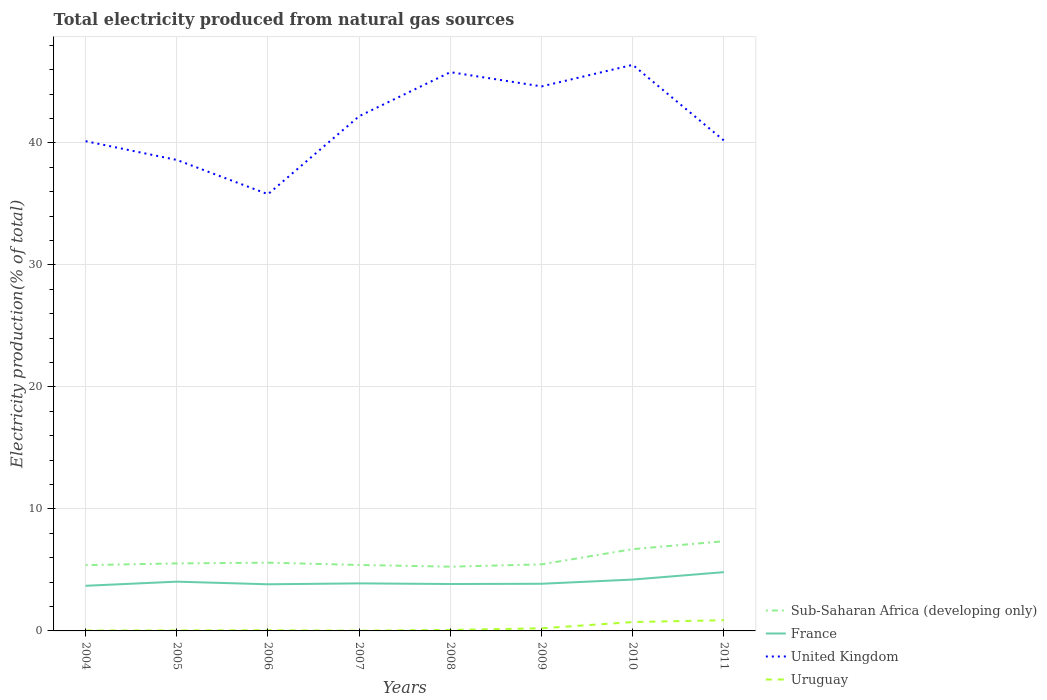How many different coloured lines are there?
Keep it short and to the point. 4. Is the number of lines equal to the number of legend labels?
Your response must be concise. Yes. Across all years, what is the maximum total electricity produced in Uruguay?
Offer a terse response. 0.02. In which year was the total electricity produced in United Kingdom maximum?
Give a very brief answer. 2006. What is the total total electricity produced in Uruguay in the graph?
Your response must be concise. -0.06. What is the difference between the highest and the second highest total electricity produced in France?
Offer a very short reply. 1.12. What is the difference between the highest and the lowest total electricity produced in Uruguay?
Provide a short and direct response. 2. Is the total electricity produced in Sub-Saharan Africa (developing only) strictly greater than the total electricity produced in United Kingdom over the years?
Make the answer very short. Yes. How many lines are there?
Provide a short and direct response. 4. How many years are there in the graph?
Give a very brief answer. 8. Does the graph contain grids?
Your answer should be very brief. Yes. Where does the legend appear in the graph?
Make the answer very short. Bottom right. What is the title of the graph?
Keep it short and to the point. Total electricity produced from natural gas sources. What is the label or title of the X-axis?
Your answer should be compact. Years. What is the Electricity production(% of total) in Sub-Saharan Africa (developing only) in 2004?
Make the answer very short. 5.39. What is the Electricity production(% of total) in France in 2004?
Offer a very short reply. 3.7. What is the Electricity production(% of total) of United Kingdom in 2004?
Offer a very short reply. 40.14. What is the Electricity production(% of total) in Uruguay in 2004?
Offer a very short reply. 0.03. What is the Electricity production(% of total) of Sub-Saharan Africa (developing only) in 2005?
Offer a very short reply. 5.53. What is the Electricity production(% of total) in France in 2005?
Your response must be concise. 4.04. What is the Electricity production(% of total) of United Kingdom in 2005?
Give a very brief answer. 38.6. What is the Electricity production(% of total) in Uruguay in 2005?
Keep it short and to the point. 0.04. What is the Electricity production(% of total) of Sub-Saharan Africa (developing only) in 2006?
Give a very brief answer. 5.59. What is the Electricity production(% of total) in France in 2006?
Offer a terse response. 3.82. What is the Electricity production(% of total) of United Kingdom in 2006?
Ensure brevity in your answer.  35.8. What is the Electricity production(% of total) in Uruguay in 2006?
Your answer should be very brief. 0.05. What is the Electricity production(% of total) in Sub-Saharan Africa (developing only) in 2007?
Offer a terse response. 5.41. What is the Electricity production(% of total) of France in 2007?
Your answer should be compact. 3.9. What is the Electricity production(% of total) in United Kingdom in 2007?
Keep it short and to the point. 42.19. What is the Electricity production(% of total) in Uruguay in 2007?
Offer a terse response. 0.02. What is the Electricity production(% of total) in Sub-Saharan Africa (developing only) in 2008?
Make the answer very short. 5.27. What is the Electricity production(% of total) in France in 2008?
Make the answer very short. 3.84. What is the Electricity production(% of total) in United Kingdom in 2008?
Your answer should be compact. 45.8. What is the Electricity production(% of total) in Uruguay in 2008?
Give a very brief answer. 0.08. What is the Electricity production(% of total) of Sub-Saharan Africa (developing only) in 2009?
Offer a very short reply. 5.46. What is the Electricity production(% of total) of France in 2009?
Provide a succinct answer. 3.86. What is the Electricity production(% of total) of United Kingdom in 2009?
Your response must be concise. 44.63. What is the Electricity production(% of total) in Uruguay in 2009?
Keep it short and to the point. 0.21. What is the Electricity production(% of total) in Sub-Saharan Africa (developing only) in 2010?
Your answer should be very brief. 6.7. What is the Electricity production(% of total) in France in 2010?
Your answer should be very brief. 4.21. What is the Electricity production(% of total) of United Kingdom in 2010?
Give a very brief answer. 46.39. What is the Electricity production(% of total) in Uruguay in 2010?
Give a very brief answer. 0.73. What is the Electricity production(% of total) in Sub-Saharan Africa (developing only) in 2011?
Offer a very short reply. 7.35. What is the Electricity production(% of total) of France in 2011?
Give a very brief answer. 4.82. What is the Electricity production(% of total) in United Kingdom in 2011?
Your response must be concise. 40.19. What is the Electricity production(% of total) in Uruguay in 2011?
Offer a terse response. 0.88. Across all years, what is the maximum Electricity production(% of total) in Sub-Saharan Africa (developing only)?
Keep it short and to the point. 7.35. Across all years, what is the maximum Electricity production(% of total) in France?
Your response must be concise. 4.82. Across all years, what is the maximum Electricity production(% of total) of United Kingdom?
Your answer should be compact. 46.39. Across all years, what is the maximum Electricity production(% of total) of Uruguay?
Your answer should be very brief. 0.88. Across all years, what is the minimum Electricity production(% of total) in Sub-Saharan Africa (developing only)?
Keep it short and to the point. 5.27. Across all years, what is the minimum Electricity production(% of total) in France?
Keep it short and to the point. 3.7. Across all years, what is the minimum Electricity production(% of total) of United Kingdom?
Provide a succinct answer. 35.8. Across all years, what is the minimum Electricity production(% of total) of Uruguay?
Ensure brevity in your answer.  0.02. What is the total Electricity production(% of total) of Sub-Saharan Africa (developing only) in the graph?
Give a very brief answer. 46.7. What is the total Electricity production(% of total) of France in the graph?
Your answer should be compact. 32.2. What is the total Electricity production(% of total) in United Kingdom in the graph?
Make the answer very short. 333.74. What is the total Electricity production(% of total) in Uruguay in the graph?
Give a very brief answer. 2.05. What is the difference between the Electricity production(% of total) of Sub-Saharan Africa (developing only) in 2004 and that in 2005?
Your response must be concise. -0.14. What is the difference between the Electricity production(% of total) of France in 2004 and that in 2005?
Offer a terse response. -0.34. What is the difference between the Electricity production(% of total) of United Kingdom in 2004 and that in 2005?
Your answer should be compact. 1.54. What is the difference between the Electricity production(% of total) in Uruguay in 2004 and that in 2005?
Provide a short and direct response. -0.01. What is the difference between the Electricity production(% of total) in Sub-Saharan Africa (developing only) in 2004 and that in 2006?
Provide a succinct answer. -0.2. What is the difference between the Electricity production(% of total) of France in 2004 and that in 2006?
Keep it short and to the point. -0.12. What is the difference between the Electricity production(% of total) in United Kingdom in 2004 and that in 2006?
Offer a terse response. 4.35. What is the difference between the Electricity production(% of total) in Uruguay in 2004 and that in 2006?
Ensure brevity in your answer.  -0.02. What is the difference between the Electricity production(% of total) in Sub-Saharan Africa (developing only) in 2004 and that in 2007?
Make the answer very short. -0.01. What is the difference between the Electricity production(% of total) in France in 2004 and that in 2007?
Offer a very short reply. -0.2. What is the difference between the Electricity production(% of total) in United Kingdom in 2004 and that in 2007?
Your response must be concise. -2.05. What is the difference between the Electricity production(% of total) of Uruguay in 2004 and that in 2007?
Ensure brevity in your answer.  0.01. What is the difference between the Electricity production(% of total) in Sub-Saharan Africa (developing only) in 2004 and that in 2008?
Your answer should be very brief. 0.13. What is the difference between the Electricity production(% of total) in France in 2004 and that in 2008?
Provide a short and direct response. -0.14. What is the difference between the Electricity production(% of total) of United Kingdom in 2004 and that in 2008?
Ensure brevity in your answer.  -5.66. What is the difference between the Electricity production(% of total) in Uruguay in 2004 and that in 2008?
Your response must be concise. -0.05. What is the difference between the Electricity production(% of total) in Sub-Saharan Africa (developing only) in 2004 and that in 2009?
Keep it short and to the point. -0.06. What is the difference between the Electricity production(% of total) of France in 2004 and that in 2009?
Make the answer very short. -0.17. What is the difference between the Electricity production(% of total) in United Kingdom in 2004 and that in 2009?
Your answer should be very brief. -4.49. What is the difference between the Electricity production(% of total) in Uruguay in 2004 and that in 2009?
Make the answer very short. -0.18. What is the difference between the Electricity production(% of total) in Sub-Saharan Africa (developing only) in 2004 and that in 2010?
Your response must be concise. -1.31. What is the difference between the Electricity production(% of total) of France in 2004 and that in 2010?
Provide a short and direct response. -0.51. What is the difference between the Electricity production(% of total) of United Kingdom in 2004 and that in 2010?
Ensure brevity in your answer.  -6.25. What is the difference between the Electricity production(% of total) of Uruguay in 2004 and that in 2010?
Your answer should be compact. -0.69. What is the difference between the Electricity production(% of total) of Sub-Saharan Africa (developing only) in 2004 and that in 2011?
Offer a terse response. -1.96. What is the difference between the Electricity production(% of total) of France in 2004 and that in 2011?
Keep it short and to the point. -1.12. What is the difference between the Electricity production(% of total) of United Kingdom in 2004 and that in 2011?
Offer a very short reply. -0.05. What is the difference between the Electricity production(% of total) in Uruguay in 2004 and that in 2011?
Offer a terse response. -0.85. What is the difference between the Electricity production(% of total) in Sub-Saharan Africa (developing only) in 2005 and that in 2006?
Give a very brief answer. -0.06. What is the difference between the Electricity production(% of total) in France in 2005 and that in 2006?
Make the answer very short. 0.21. What is the difference between the Electricity production(% of total) in United Kingdom in 2005 and that in 2006?
Provide a short and direct response. 2.81. What is the difference between the Electricity production(% of total) in Uruguay in 2005 and that in 2006?
Make the answer very short. -0.01. What is the difference between the Electricity production(% of total) of Sub-Saharan Africa (developing only) in 2005 and that in 2007?
Your answer should be very brief. 0.13. What is the difference between the Electricity production(% of total) in France in 2005 and that in 2007?
Offer a terse response. 0.14. What is the difference between the Electricity production(% of total) in United Kingdom in 2005 and that in 2007?
Ensure brevity in your answer.  -3.59. What is the difference between the Electricity production(% of total) in Uruguay in 2005 and that in 2007?
Provide a short and direct response. 0.02. What is the difference between the Electricity production(% of total) in Sub-Saharan Africa (developing only) in 2005 and that in 2008?
Offer a terse response. 0.27. What is the difference between the Electricity production(% of total) of France in 2005 and that in 2008?
Offer a very short reply. 0.19. What is the difference between the Electricity production(% of total) of United Kingdom in 2005 and that in 2008?
Your answer should be very brief. -7.2. What is the difference between the Electricity production(% of total) in Uruguay in 2005 and that in 2008?
Offer a very short reply. -0.04. What is the difference between the Electricity production(% of total) of Sub-Saharan Africa (developing only) in 2005 and that in 2009?
Ensure brevity in your answer.  0.08. What is the difference between the Electricity production(% of total) in France in 2005 and that in 2009?
Keep it short and to the point. 0.17. What is the difference between the Electricity production(% of total) of United Kingdom in 2005 and that in 2009?
Give a very brief answer. -6.03. What is the difference between the Electricity production(% of total) in Uruguay in 2005 and that in 2009?
Offer a terse response. -0.18. What is the difference between the Electricity production(% of total) of Sub-Saharan Africa (developing only) in 2005 and that in 2010?
Offer a terse response. -1.17. What is the difference between the Electricity production(% of total) of France in 2005 and that in 2010?
Offer a terse response. -0.17. What is the difference between the Electricity production(% of total) of United Kingdom in 2005 and that in 2010?
Keep it short and to the point. -7.79. What is the difference between the Electricity production(% of total) in Uruguay in 2005 and that in 2010?
Offer a terse response. -0.69. What is the difference between the Electricity production(% of total) in Sub-Saharan Africa (developing only) in 2005 and that in 2011?
Your response must be concise. -1.82. What is the difference between the Electricity production(% of total) in France in 2005 and that in 2011?
Ensure brevity in your answer.  -0.78. What is the difference between the Electricity production(% of total) in United Kingdom in 2005 and that in 2011?
Ensure brevity in your answer.  -1.59. What is the difference between the Electricity production(% of total) in Uruguay in 2005 and that in 2011?
Keep it short and to the point. -0.84. What is the difference between the Electricity production(% of total) in Sub-Saharan Africa (developing only) in 2006 and that in 2007?
Make the answer very short. 0.19. What is the difference between the Electricity production(% of total) of France in 2006 and that in 2007?
Keep it short and to the point. -0.07. What is the difference between the Electricity production(% of total) of United Kingdom in 2006 and that in 2007?
Offer a terse response. -6.39. What is the difference between the Electricity production(% of total) in Uruguay in 2006 and that in 2007?
Your answer should be compact. 0.03. What is the difference between the Electricity production(% of total) in Sub-Saharan Africa (developing only) in 2006 and that in 2008?
Offer a very short reply. 0.33. What is the difference between the Electricity production(% of total) of France in 2006 and that in 2008?
Provide a short and direct response. -0.02. What is the difference between the Electricity production(% of total) in United Kingdom in 2006 and that in 2008?
Your answer should be compact. -10. What is the difference between the Electricity production(% of total) of Uruguay in 2006 and that in 2008?
Provide a succinct answer. -0.03. What is the difference between the Electricity production(% of total) of Sub-Saharan Africa (developing only) in 2006 and that in 2009?
Your response must be concise. 0.14. What is the difference between the Electricity production(% of total) in France in 2006 and that in 2009?
Ensure brevity in your answer.  -0.04. What is the difference between the Electricity production(% of total) in United Kingdom in 2006 and that in 2009?
Keep it short and to the point. -8.83. What is the difference between the Electricity production(% of total) in Uruguay in 2006 and that in 2009?
Give a very brief answer. -0.16. What is the difference between the Electricity production(% of total) in Sub-Saharan Africa (developing only) in 2006 and that in 2010?
Ensure brevity in your answer.  -1.11. What is the difference between the Electricity production(% of total) of France in 2006 and that in 2010?
Keep it short and to the point. -0.39. What is the difference between the Electricity production(% of total) in United Kingdom in 2006 and that in 2010?
Offer a very short reply. -10.6. What is the difference between the Electricity production(% of total) in Uruguay in 2006 and that in 2010?
Provide a succinct answer. -0.67. What is the difference between the Electricity production(% of total) in Sub-Saharan Africa (developing only) in 2006 and that in 2011?
Make the answer very short. -1.76. What is the difference between the Electricity production(% of total) in France in 2006 and that in 2011?
Offer a very short reply. -1. What is the difference between the Electricity production(% of total) in United Kingdom in 2006 and that in 2011?
Your response must be concise. -4.4. What is the difference between the Electricity production(% of total) in Uruguay in 2006 and that in 2011?
Offer a terse response. -0.83. What is the difference between the Electricity production(% of total) in Sub-Saharan Africa (developing only) in 2007 and that in 2008?
Keep it short and to the point. 0.14. What is the difference between the Electricity production(% of total) in France in 2007 and that in 2008?
Your answer should be very brief. 0.05. What is the difference between the Electricity production(% of total) in United Kingdom in 2007 and that in 2008?
Ensure brevity in your answer.  -3.61. What is the difference between the Electricity production(% of total) of Uruguay in 2007 and that in 2008?
Keep it short and to the point. -0.06. What is the difference between the Electricity production(% of total) in Sub-Saharan Africa (developing only) in 2007 and that in 2009?
Provide a succinct answer. -0.05. What is the difference between the Electricity production(% of total) of France in 2007 and that in 2009?
Provide a succinct answer. 0.03. What is the difference between the Electricity production(% of total) of United Kingdom in 2007 and that in 2009?
Ensure brevity in your answer.  -2.44. What is the difference between the Electricity production(% of total) in Uruguay in 2007 and that in 2009?
Your answer should be very brief. -0.19. What is the difference between the Electricity production(% of total) of Sub-Saharan Africa (developing only) in 2007 and that in 2010?
Give a very brief answer. -1.3. What is the difference between the Electricity production(% of total) of France in 2007 and that in 2010?
Give a very brief answer. -0.31. What is the difference between the Electricity production(% of total) in United Kingdom in 2007 and that in 2010?
Offer a very short reply. -4.21. What is the difference between the Electricity production(% of total) of Uruguay in 2007 and that in 2010?
Make the answer very short. -0.71. What is the difference between the Electricity production(% of total) of Sub-Saharan Africa (developing only) in 2007 and that in 2011?
Offer a very short reply. -1.94. What is the difference between the Electricity production(% of total) of France in 2007 and that in 2011?
Offer a terse response. -0.92. What is the difference between the Electricity production(% of total) of United Kingdom in 2007 and that in 2011?
Provide a succinct answer. 2. What is the difference between the Electricity production(% of total) in Uruguay in 2007 and that in 2011?
Provide a succinct answer. -0.86. What is the difference between the Electricity production(% of total) in Sub-Saharan Africa (developing only) in 2008 and that in 2009?
Provide a short and direct response. -0.19. What is the difference between the Electricity production(% of total) in France in 2008 and that in 2009?
Offer a very short reply. -0.02. What is the difference between the Electricity production(% of total) in United Kingdom in 2008 and that in 2009?
Ensure brevity in your answer.  1.17. What is the difference between the Electricity production(% of total) of Uruguay in 2008 and that in 2009?
Make the answer very short. -0.13. What is the difference between the Electricity production(% of total) in Sub-Saharan Africa (developing only) in 2008 and that in 2010?
Offer a very short reply. -1.44. What is the difference between the Electricity production(% of total) of France in 2008 and that in 2010?
Ensure brevity in your answer.  -0.36. What is the difference between the Electricity production(% of total) in United Kingdom in 2008 and that in 2010?
Keep it short and to the point. -0.6. What is the difference between the Electricity production(% of total) of Uruguay in 2008 and that in 2010?
Give a very brief answer. -0.65. What is the difference between the Electricity production(% of total) of Sub-Saharan Africa (developing only) in 2008 and that in 2011?
Your response must be concise. -2.08. What is the difference between the Electricity production(% of total) in France in 2008 and that in 2011?
Keep it short and to the point. -0.97. What is the difference between the Electricity production(% of total) in United Kingdom in 2008 and that in 2011?
Give a very brief answer. 5.6. What is the difference between the Electricity production(% of total) of Uruguay in 2008 and that in 2011?
Give a very brief answer. -0.8. What is the difference between the Electricity production(% of total) in Sub-Saharan Africa (developing only) in 2009 and that in 2010?
Provide a short and direct response. -1.25. What is the difference between the Electricity production(% of total) of France in 2009 and that in 2010?
Your answer should be compact. -0.34. What is the difference between the Electricity production(% of total) in United Kingdom in 2009 and that in 2010?
Make the answer very short. -1.77. What is the difference between the Electricity production(% of total) of Uruguay in 2009 and that in 2010?
Offer a terse response. -0.51. What is the difference between the Electricity production(% of total) of Sub-Saharan Africa (developing only) in 2009 and that in 2011?
Make the answer very short. -1.9. What is the difference between the Electricity production(% of total) of France in 2009 and that in 2011?
Ensure brevity in your answer.  -0.95. What is the difference between the Electricity production(% of total) of United Kingdom in 2009 and that in 2011?
Make the answer very short. 4.44. What is the difference between the Electricity production(% of total) in Uruguay in 2009 and that in 2011?
Give a very brief answer. -0.67. What is the difference between the Electricity production(% of total) of Sub-Saharan Africa (developing only) in 2010 and that in 2011?
Keep it short and to the point. -0.65. What is the difference between the Electricity production(% of total) in France in 2010 and that in 2011?
Make the answer very short. -0.61. What is the difference between the Electricity production(% of total) in United Kingdom in 2010 and that in 2011?
Make the answer very short. 6.2. What is the difference between the Electricity production(% of total) of Uruguay in 2010 and that in 2011?
Give a very brief answer. -0.15. What is the difference between the Electricity production(% of total) of Sub-Saharan Africa (developing only) in 2004 and the Electricity production(% of total) of France in 2005?
Provide a succinct answer. 1.36. What is the difference between the Electricity production(% of total) in Sub-Saharan Africa (developing only) in 2004 and the Electricity production(% of total) in United Kingdom in 2005?
Your answer should be compact. -33.21. What is the difference between the Electricity production(% of total) in Sub-Saharan Africa (developing only) in 2004 and the Electricity production(% of total) in Uruguay in 2005?
Provide a short and direct response. 5.36. What is the difference between the Electricity production(% of total) of France in 2004 and the Electricity production(% of total) of United Kingdom in 2005?
Offer a very short reply. -34.9. What is the difference between the Electricity production(% of total) in France in 2004 and the Electricity production(% of total) in Uruguay in 2005?
Provide a short and direct response. 3.66. What is the difference between the Electricity production(% of total) in United Kingdom in 2004 and the Electricity production(% of total) in Uruguay in 2005?
Provide a short and direct response. 40.1. What is the difference between the Electricity production(% of total) of Sub-Saharan Africa (developing only) in 2004 and the Electricity production(% of total) of France in 2006?
Your response must be concise. 1.57. What is the difference between the Electricity production(% of total) of Sub-Saharan Africa (developing only) in 2004 and the Electricity production(% of total) of United Kingdom in 2006?
Give a very brief answer. -30.4. What is the difference between the Electricity production(% of total) of Sub-Saharan Africa (developing only) in 2004 and the Electricity production(% of total) of Uruguay in 2006?
Make the answer very short. 5.34. What is the difference between the Electricity production(% of total) of France in 2004 and the Electricity production(% of total) of United Kingdom in 2006?
Provide a succinct answer. -32.1. What is the difference between the Electricity production(% of total) of France in 2004 and the Electricity production(% of total) of Uruguay in 2006?
Keep it short and to the point. 3.65. What is the difference between the Electricity production(% of total) in United Kingdom in 2004 and the Electricity production(% of total) in Uruguay in 2006?
Your response must be concise. 40.09. What is the difference between the Electricity production(% of total) in Sub-Saharan Africa (developing only) in 2004 and the Electricity production(% of total) in France in 2007?
Make the answer very short. 1.5. What is the difference between the Electricity production(% of total) of Sub-Saharan Africa (developing only) in 2004 and the Electricity production(% of total) of United Kingdom in 2007?
Give a very brief answer. -36.8. What is the difference between the Electricity production(% of total) in Sub-Saharan Africa (developing only) in 2004 and the Electricity production(% of total) in Uruguay in 2007?
Offer a terse response. 5.37. What is the difference between the Electricity production(% of total) in France in 2004 and the Electricity production(% of total) in United Kingdom in 2007?
Give a very brief answer. -38.49. What is the difference between the Electricity production(% of total) of France in 2004 and the Electricity production(% of total) of Uruguay in 2007?
Provide a succinct answer. 3.68. What is the difference between the Electricity production(% of total) of United Kingdom in 2004 and the Electricity production(% of total) of Uruguay in 2007?
Make the answer very short. 40.12. What is the difference between the Electricity production(% of total) in Sub-Saharan Africa (developing only) in 2004 and the Electricity production(% of total) in France in 2008?
Make the answer very short. 1.55. What is the difference between the Electricity production(% of total) of Sub-Saharan Africa (developing only) in 2004 and the Electricity production(% of total) of United Kingdom in 2008?
Ensure brevity in your answer.  -40.4. What is the difference between the Electricity production(% of total) of Sub-Saharan Africa (developing only) in 2004 and the Electricity production(% of total) of Uruguay in 2008?
Your answer should be very brief. 5.31. What is the difference between the Electricity production(% of total) in France in 2004 and the Electricity production(% of total) in United Kingdom in 2008?
Keep it short and to the point. -42.1. What is the difference between the Electricity production(% of total) of France in 2004 and the Electricity production(% of total) of Uruguay in 2008?
Give a very brief answer. 3.62. What is the difference between the Electricity production(% of total) in United Kingdom in 2004 and the Electricity production(% of total) in Uruguay in 2008?
Your answer should be compact. 40.06. What is the difference between the Electricity production(% of total) in Sub-Saharan Africa (developing only) in 2004 and the Electricity production(% of total) in France in 2009?
Provide a succinct answer. 1.53. What is the difference between the Electricity production(% of total) in Sub-Saharan Africa (developing only) in 2004 and the Electricity production(% of total) in United Kingdom in 2009?
Your response must be concise. -39.24. What is the difference between the Electricity production(% of total) of Sub-Saharan Africa (developing only) in 2004 and the Electricity production(% of total) of Uruguay in 2009?
Provide a succinct answer. 5.18. What is the difference between the Electricity production(% of total) in France in 2004 and the Electricity production(% of total) in United Kingdom in 2009?
Make the answer very short. -40.93. What is the difference between the Electricity production(% of total) of France in 2004 and the Electricity production(% of total) of Uruguay in 2009?
Provide a succinct answer. 3.49. What is the difference between the Electricity production(% of total) of United Kingdom in 2004 and the Electricity production(% of total) of Uruguay in 2009?
Keep it short and to the point. 39.93. What is the difference between the Electricity production(% of total) of Sub-Saharan Africa (developing only) in 2004 and the Electricity production(% of total) of France in 2010?
Your answer should be compact. 1.18. What is the difference between the Electricity production(% of total) of Sub-Saharan Africa (developing only) in 2004 and the Electricity production(% of total) of United Kingdom in 2010?
Give a very brief answer. -41. What is the difference between the Electricity production(% of total) in Sub-Saharan Africa (developing only) in 2004 and the Electricity production(% of total) in Uruguay in 2010?
Your answer should be compact. 4.67. What is the difference between the Electricity production(% of total) of France in 2004 and the Electricity production(% of total) of United Kingdom in 2010?
Offer a terse response. -42.7. What is the difference between the Electricity production(% of total) of France in 2004 and the Electricity production(% of total) of Uruguay in 2010?
Keep it short and to the point. 2.97. What is the difference between the Electricity production(% of total) in United Kingdom in 2004 and the Electricity production(% of total) in Uruguay in 2010?
Offer a terse response. 39.41. What is the difference between the Electricity production(% of total) in Sub-Saharan Africa (developing only) in 2004 and the Electricity production(% of total) in France in 2011?
Your answer should be compact. 0.58. What is the difference between the Electricity production(% of total) in Sub-Saharan Africa (developing only) in 2004 and the Electricity production(% of total) in United Kingdom in 2011?
Your response must be concise. -34.8. What is the difference between the Electricity production(% of total) of Sub-Saharan Africa (developing only) in 2004 and the Electricity production(% of total) of Uruguay in 2011?
Provide a short and direct response. 4.51. What is the difference between the Electricity production(% of total) in France in 2004 and the Electricity production(% of total) in United Kingdom in 2011?
Provide a succinct answer. -36.49. What is the difference between the Electricity production(% of total) of France in 2004 and the Electricity production(% of total) of Uruguay in 2011?
Your answer should be compact. 2.82. What is the difference between the Electricity production(% of total) in United Kingdom in 2004 and the Electricity production(% of total) in Uruguay in 2011?
Offer a very short reply. 39.26. What is the difference between the Electricity production(% of total) of Sub-Saharan Africa (developing only) in 2005 and the Electricity production(% of total) of France in 2006?
Your answer should be compact. 1.71. What is the difference between the Electricity production(% of total) in Sub-Saharan Africa (developing only) in 2005 and the Electricity production(% of total) in United Kingdom in 2006?
Your response must be concise. -30.26. What is the difference between the Electricity production(% of total) of Sub-Saharan Africa (developing only) in 2005 and the Electricity production(% of total) of Uruguay in 2006?
Provide a succinct answer. 5.48. What is the difference between the Electricity production(% of total) in France in 2005 and the Electricity production(% of total) in United Kingdom in 2006?
Your answer should be compact. -31.76. What is the difference between the Electricity production(% of total) of France in 2005 and the Electricity production(% of total) of Uruguay in 2006?
Offer a very short reply. 3.98. What is the difference between the Electricity production(% of total) of United Kingdom in 2005 and the Electricity production(% of total) of Uruguay in 2006?
Make the answer very short. 38.55. What is the difference between the Electricity production(% of total) of Sub-Saharan Africa (developing only) in 2005 and the Electricity production(% of total) of France in 2007?
Offer a terse response. 1.64. What is the difference between the Electricity production(% of total) of Sub-Saharan Africa (developing only) in 2005 and the Electricity production(% of total) of United Kingdom in 2007?
Offer a terse response. -36.66. What is the difference between the Electricity production(% of total) of Sub-Saharan Africa (developing only) in 2005 and the Electricity production(% of total) of Uruguay in 2007?
Offer a terse response. 5.51. What is the difference between the Electricity production(% of total) of France in 2005 and the Electricity production(% of total) of United Kingdom in 2007?
Your response must be concise. -38.15. What is the difference between the Electricity production(% of total) in France in 2005 and the Electricity production(% of total) in Uruguay in 2007?
Give a very brief answer. 4.02. What is the difference between the Electricity production(% of total) of United Kingdom in 2005 and the Electricity production(% of total) of Uruguay in 2007?
Your answer should be compact. 38.58. What is the difference between the Electricity production(% of total) of Sub-Saharan Africa (developing only) in 2005 and the Electricity production(% of total) of France in 2008?
Offer a very short reply. 1.69. What is the difference between the Electricity production(% of total) in Sub-Saharan Africa (developing only) in 2005 and the Electricity production(% of total) in United Kingdom in 2008?
Keep it short and to the point. -40.26. What is the difference between the Electricity production(% of total) in Sub-Saharan Africa (developing only) in 2005 and the Electricity production(% of total) in Uruguay in 2008?
Offer a very short reply. 5.45. What is the difference between the Electricity production(% of total) of France in 2005 and the Electricity production(% of total) of United Kingdom in 2008?
Give a very brief answer. -41.76. What is the difference between the Electricity production(% of total) in France in 2005 and the Electricity production(% of total) in Uruguay in 2008?
Provide a succinct answer. 3.96. What is the difference between the Electricity production(% of total) in United Kingdom in 2005 and the Electricity production(% of total) in Uruguay in 2008?
Your answer should be compact. 38.52. What is the difference between the Electricity production(% of total) of Sub-Saharan Africa (developing only) in 2005 and the Electricity production(% of total) of France in 2009?
Your answer should be very brief. 1.67. What is the difference between the Electricity production(% of total) of Sub-Saharan Africa (developing only) in 2005 and the Electricity production(% of total) of United Kingdom in 2009?
Give a very brief answer. -39.1. What is the difference between the Electricity production(% of total) in Sub-Saharan Africa (developing only) in 2005 and the Electricity production(% of total) in Uruguay in 2009?
Your answer should be compact. 5.32. What is the difference between the Electricity production(% of total) in France in 2005 and the Electricity production(% of total) in United Kingdom in 2009?
Provide a succinct answer. -40.59. What is the difference between the Electricity production(% of total) in France in 2005 and the Electricity production(% of total) in Uruguay in 2009?
Make the answer very short. 3.82. What is the difference between the Electricity production(% of total) of United Kingdom in 2005 and the Electricity production(% of total) of Uruguay in 2009?
Your answer should be compact. 38.39. What is the difference between the Electricity production(% of total) of Sub-Saharan Africa (developing only) in 2005 and the Electricity production(% of total) of France in 2010?
Ensure brevity in your answer.  1.32. What is the difference between the Electricity production(% of total) of Sub-Saharan Africa (developing only) in 2005 and the Electricity production(% of total) of United Kingdom in 2010?
Provide a short and direct response. -40.86. What is the difference between the Electricity production(% of total) of Sub-Saharan Africa (developing only) in 2005 and the Electricity production(% of total) of Uruguay in 2010?
Your answer should be compact. 4.8. What is the difference between the Electricity production(% of total) of France in 2005 and the Electricity production(% of total) of United Kingdom in 2010?
Ensure brevity in your answer.  -42.36. What is the difference between the Electricity production(% of total) of France in 2005 and the Electricity production(% of total) of Uruguay in 2010?
Give a very brief answer. 3.31. What is the difference between the Electricity production(% of total) in United Kingdom in 2005 and the Electricity production(% of total) in Uruguay in 2010?
Your answer should be compact. 37.87. What is the difference between the Electricity production(% of total) in Sub-Saharan Africa (developing only) in 2005 and the Electricity production(% of total) in France in 2011?
Your answer should be very brief. 0.71. What is the difference between the Electricity production(% of total) of Sub-Saharan Africa (developing only) in 2005 and the Electricity production(% of total) of United Kingdom in 2011?
Make the answer very short. -34.66. What is the difference between the Electricity production(% of total) in Sub-Saharan Africa (developing only) in 2005 and the Electricity production(% of total) in Uruguay in 2011?
Your response must be concise. 4.65. What is the difference between the Electricity production(% of total) in France in 2005 and the Electricity production(% of total) in United Kingdom in 2011?
Your answer should be compact. -36.15. What is the difference between the Electricity production(% of total) of France in 2005 and the Electricity production(% of total) of Uruguay in 2011?
Your answer should be very brief. 3.16. What is the difference between the Electricity production(% of total) in United Kingdom in 2005 and the Electricity production(% of total) in Uruguay in 2011?
Your answer should be compact. 37.72. What is the difference between the Electricity production(% of total) of Sub-Saharan Africa (developing only) in 2006 and the Electricity production(% of total) of France in 2007?
Your answer should be compact. 1.7. What is the difference between the Electricity production(% of total) in Sub-Saharan Africa (developing only) in 2006 and the Electricity production(% of total) in United Kingdom in 2007?
Make the answer very short. -36.6. What is the difference between the Electricity production(% of total) of Sub-Saharan Africa (developing only) in 2006 and the Electricity production(% of total) of Uruguay in 2007?
Keep it short and to the point. 5.57. What is the difference between the Electricity production(% of total) of France in 2006 and the Electricity production(% of total) of United Kingdom in 2007?
Provide a succinct answer. -38.37. What is the difference between the Electricity production(% of total) in France in 2006 and the Electricity production(% of total) in Uruguay in 2007?
Offer a very short reply. 3.8. What is the difference between the Electricity production(% of total) of United Kingdom in 2006 and the Electricity production(% of total) of Uruguay in 2007?
Provide a short and direct response. 35.77. What is the difference between the Electricity production(% of total) of Sub-Saharan Africa (developing only) in 2006 and the Electricity production(% of total) of France in 2008?
Your answer should be very brief. 1.75. What is the difference between the Electricity production(% of total) of Sub-Saharan Africa (developing only) in 2006 and the Electricity production(% of total) of United Kingdom in 2008?
Ensure brevity in your answer.  -40.2. What is the difference between the Electricity production(% of total) of Sub-Saharan Africa (developing only) in 2006 and the Electricity production(% of total) of Uruguay in 2008?
Keep it short and to the point. 5.51. What is the difference between the Electricity production(% of total) in France in 2006 and the Electricity production(% of total) in United Kingdom in 2008?
Offer a very short reply. -41.97. What is the difference between the Electricity production(% of total) of France in 2006 and the Electricity production(% of total) of Uruguay in 2008?
Ensure brevity in your answer.  3.74. What is the difference between the Electricity production(% of total) of United Kingdom in 2006 and the Electricity production(% of total) of Uruguay in 2008?
Your response must be concise. 35.72. What is the difference between the Electricity production(% of total) of Sub-Saharan Africa (developing only) in 2006 and the Electricity production(% of total) of France in 2009?
Offer a very short reply. 1.73. What is the difference between the Electricity production(% of total) of Sub-Saharan Africa (developing only) in 2006 and the Electricity production(% of total) of United Kingdom in 2009?
Offer a very short reply. -39.04. What is the difference between the Electricity production(% of total) in Sub-Saharan Africa (developing only) in 2006 and the Electricity production(% of total) in Uruguay in 2009?
Your answer should be very brief. 5.38. What is the difference between the Electricity production(% of total) in France in 2006 and the Electricity production(% of total) in United Kingdom in 2009?
Keep it short and to the point. -40.81. What is the difference between the Electricity production(% of total) in France in 2006 and the Electricity production(% of total) in Uruguay in 2009?
Give a very brief answer. 3.61. What is the difference between the Electricity production(% of total) in United Kingdom in 2006 and the Electricity production(% of total) in Uruguay in 2009?
Your response must be concise. 35.58. What is the difference between the Electricity production(% of total) of Sub-Saharan Africa (developing only) in 2006 and the Electricity production(% of total) of France in 2010?
Your response must be concise. 1.38. What is the difference between the Electricity production(% of total) in Sub-Saharan Africa (developing only) in 2006 and the Electricity production(% of total) in United Kingdom in 2010?
Your answer should be compact. -40.8. What is the difference between the Electricity production(% of total) in Sub-Saharan Africa (developing only) in 2006 and the Electricity production(% of total) in Uruguay in 2010?
Your answer should be compact. 4.87. What is the difference between the Electricity production(% of total) of France in 2006 and the Electricity production(% of total) of United Kingdom in 2010?
Offer a terse response. -42.57. What is the difference between the Electricity production(% of total) in France in 2006 and the Electricity production(% of total) in Uruguay in 2010?
Give a very brief answer. 3.1. What is the difference between the Electricity production(% of total) in United Kingdom in 2006 and the Electricity production(% of total) in Uruguay in 2010?
Keep it short and to the point. 35.07. What is the difference between the Electricity production(% of total) in Sub-Saharan Africa (developing only) in 2006 and the Electricity production(% of total) in France in 2011?
Make the answer very short. 0.77. What is the difference between the Electricity production(% of total) of Sub-Saharan Africa (developing only) in 2006 and the Electricity production(% of total) of United Kingdom in 2011?
Your answer should be very brief. -34.6. What is the difference between the Electricity production(% of total) in Sub-Saharan Africa (developing only) in 2006 and the Electricity production(% of total) in Uruguay in 2011?
Your response must be concise. 4.71. What is the difference between the Electricity production(% of total) of France in 2006 and the Electricity production(% of total) of United Kingdom in 2011?
Give a very brief answer. -36.37. What is the difference between the Electricity production(% of total) in France in 2006 and the Electricity production(% of total) in Uruguay in 2011?
Ensure brevity in your answer.  2.94. What is the difference between the Electricity production(% of total) of United Kingdom in 2006 and the Electricity production(% of total) of Uruguay in 2011?
Your answer should be compact. 34.92. What is the difference between the Electricity production(% of total) of Sub-Saharan Africa (developing only) in 2007 and the Electricity production(% of total) of France in 2008?
Your response must be concise. 1.56. What is the difference between the Electricity production(% of total) in Sub-Saharan Africa (developing only) in 2007 and the Electricity production(% of total) in United Kingdom in 2008?
Offer a terse response. -40.39. What is the difference between the Electricity production(% of total) of Sub-Saharan Africa (developing only) in 2007 and the Electricity production(% of total) of Uruguay in 2008?
Provide a succinct answer. 5.33. What is the difference between the Electricity production(% of total) in France in 2007 and the Electricity production(% of total) in United Kingdom in 2008?
Your answer should be compact. -41.9. What is the difference between the Electricity production(% of total) of France in 2007 and the Electricity production(% of total) of Uruguay in 2008?
Make the answer very short. 3.82. What is the difference between the Electricity production(% of total) of United Kingdom in 2007 and the Electricity production(% of total) of Uruguay in 2008?
Give a very brief answer. 42.11. What is the difference between the Electricity production(% of total) of Sub-Saharan Africa (developing only) in 2007 and the Electricity production(% of total) of France in 2009?
Your response must be concise. 1.54. What is the difference between the Electricity production(% of total) of Sub-Saharan Africa (developing only) in 2007 and the Electricity production(% of total) of United Kingdom in 2009?
Offer a very short reply. -39.22. What is the difference between the Electricity production(% of total) of Sub-Saharan Africa (developing only) in 2007 and the Electricity production(% of total) of Uruguay in 2009?
Provide a succinct answer. 5.19. What is the difference between the Electricity production(% of total) of France in 2007 and the Electricity production(% of total) of United Kingdom in 2009?
Offer a terse response. -40.73. What is the difference between the Electricity production(% of total) in France in 2007 and the Electricity production(% of total) in Uruguay in 2009?
Ensure brevity in your answer.  3.68. What is the difference between the Electricity production(% of total) in United Kingdom in 2007 and the Electricity production(% of total) in Uruguay in 2009?
Offer a terse response. 41.98. What is the difference between the Electricity production(% of total) of Sub-Saharan Africa (developing only) in 2007 and the Electricity production(% of total) of France in 2010?
Offer a terse response. 1.2. What is the difference between the Electricity production(% of total) in Sub-Saharan Africa (developing only) in 2007 and the Electricity production(% of total) in United Kingdom in 2010?
Make the answer very short. -40.99. What is the difference between the Electricity production(% of total) in Sub-Saharan Africa (developing only) in 2007 and the Electricity production(% of total) in Uruguay in 2010?
Your answer should be compact. 4.68. What is the difference between the Electricity production(% of total) in France in 2007 and the Electricity production(% of total) in United Kingdom in 2010?
Your answer should be very brief. -42.5. What is the difference between the Electricity production(% of total) in France in 2007 and the Electricity production(% of total) in Uruguay in 2010?
Ensure brevity in your answer.  3.17. What is the difference between the Electricity production(% of total) of United Kingdom in 2007 and the Electricity production(% of total) of Uruguay in 2010?
Your answer should be very brief. 41.46. What is the difference between the Electricity production(% of total) of Sub-Saharan Africa (developing only) in 2007 and the Electricity production(% of total) of France in 2011?
Your response must be concise. 0.59. What is the difference between the Electricity production(% of total) of Sub-Saharan Africa (developing only) in 2007 and the Electricity production(% of total) of United Kingdom in 2011?
Keep it short and to the point. -34.79. What is the difference between the Electricity production(% of total) in Sub-Saharan Africa (developing only) in 2007 and the Electricity production(% of total) in Uruguay in 2011?
Keep it short and to the point. 4.53. What is the difference between the Electricity production(% of total) in France in 2007 and the Electricity production(% of total) in United Kingdom in 2011?
Provide a succinct answer. -36.29. What is the difference between the Electricity production(% of total) of France in 2007 and the Electricity production(% of total) of Uruguay in 2011?
Ensure brevity in your answer.  3.02. What is the difference between the Electricity production(% of total) in United Kingdom in 2007 and the Electricity production(% of total) in Uruguay in 2011?
Provide a succinct answer. 41.31. What is the difference between the Electricity production(% of total) of Sub-Saharan Africa (developing only) in 2008 and the Electricity production(% of total) of France in 2009?
Offer a very short reply. 1.4. What is the difference between the Electricity production(% of total) of Sub-Saharan Africa (developing only) in 2008 and the Electricity production(% of total) of United Kingdom in 2009?
Your response must be concise. -39.36. What is the difference between the Electricity production(% of total) of Sub-Saharan Africa (developing only) in 2008 and the Electricity production(% of total) of Uruguay in 2009?
Provide a succinct answer. 5.05. What is the difference between the Electricity production(% of total) in France in 2008 and the Electricity production(% of total) in United Kingdom in 2009?
Provide a short and direct response. -40.78. What is the difference between the Electricity production(% of total) in France in 2008 and the Electricity production(% of total) in Uruguay in 2009?
Provide a succinct answer. 3.63. What is the difference between the Electricity production(% of total) of United Kingdom in 2008 and the Electricity production(% of total) of Uruguay in 2009?
Your answer should be very brief. 45.58. What is the difference between the Electricity production(% of total) of Sub-Saharan Africa (developing only) in 2008 and the Electricity production(% of total) of France in 2010?
Offer a terse response. 1.06. What is the difference between the Electricity production(% of total) of Sub-Saharan Africa (developing only) in 2008 and the Electricity production(% of total) of United Kingdom in 2010?
Provide a succinct answer. -41.13. What is the difference between the Electricity production(% of total) in Sub-Saharan Africa (developing only) in 2008 and the Electricity production(% of total) in Uruguay in 2010?
Ensure brevity in your answer.  4.54. What is the difference between the Electricity production(% of total) in France in 2008 and the Electricity production(% of total) in United Kingdom in 2010?
Provide a succinct answer. -42.55. What is the difference between the Electricity production(% of total) in France in 2008 and the Electricity production(% of total) in Uruguay in 2010?
Make the answer very short. 3.12. What is the difference between the Electricity production(% of total) in United Kingdom in 2008 and the Electricity production(% of total) in Uruguay in 2010?
Keep it short and to the point. 45.07. What is the difference between the Electricity production(% of total) in Sub-Saharan Africa (developing only) in 2008 and the Electricity production(% of total) in France in 2011?
Ensure brevity in your answer.  0.45. What is the difference between the Electricity production(% of total) in Sub-Saharan Africa (developing only) in 2008 and the Electricity production(% of total) in United Kingdom in 2011?
Your response must be concise. -34.93. What is the difference between the Electricity production(% of total) of Sub-Saharan Africa (developing only) in 2008 and the Electricity production(% of total) of Uruguay in 2011?
Your response must be concise. 4.39. What is the difference between the Electricity production(% of total) of France in 2008 and the Electricity production(% of total) of United Kingdom in 2011?
Your answer should be compact. -36.35. What is the difference between the Electricity production(% of total) of France in 2008 and the Electricity production(% of total) of Uruguay in 2011?
Give a very brief answer. 2.96. What is the difference between the Electricity production(% of total) of United Kingdom in 2008 and the Electricity production(% of total) of Uruguay in 2011?
Offer a terse response. 44.92. What is the difference between the Electricity production(% of total) in Sub-Saharan Africa (developing only) in 2009 and the Electricity production(% of total) in France in 2010?
Offer a terse response. 1.25. What is the difference between the Electricity production(% of total) in Sub-Saharan Africa (developing only) in 2009 and the Electricity production(% of total) in United Kingdom in 2010?
Provide a short and direct response. -40.94. What is the difference between the Electricity production(% of total) in Sub-Saharan Africa (developing only) in 2009 and the Electricity production(% of total) in Uruguay in 2010?
Make the answer very short. 4.73. What is the difference between the Electricity production(% of total) in France in 2009 and the Electricity production(% of total) in United Kingdom in 2010?
Offer a very short reply. -42.53. What is the difference between the Electricity production(% of total) in France in 2009 and the Electricity production(% of total) in Uruguay in 2010?
Your answer should be very brief. 3.14. What is the difference between the Electricity production(% of total) of United Kingdom in 2009 and the Electricity production(% of total) of Uruguay in 2010?
Provide a short and direct response. 43.9. What is the difference between the Electricity production(% of total) of Sub-Saharan Africa (developing only) in 2009 and the Electricity production(% of total) of France in 2011?
Your response must be concise. 0.64. What is the difference between the Electricity production(% of total) in Sub-Saharan Africa (developing only) in 2009 and the Electricity production(% of total) in United Kingdom in 2011?
Your answer should be compact. -34.74. What is the difference between the Electricity production(% of total) in Sub-Saharan Africa (developing only) in 2009 and the Electricity production(% of total) in Uruguay in 2011?
Keep it short and to the point. 4.58. What is the difference between the Electricity production(% of total) in France in 2009 and the Electricity production(% of total) in United Kingdom in 2011?
Provide a succinct answer. -36.33. What is the difference between the Electricity production(% of total) in France in 2009 and the Electricity production(% of total) in Uruguay in 2011?
Your response must be concise. 2.99. What is the difference between the Electricity production(% of total) in United Kingdom in 2009 and the Electricity production(% of total) in Uruguay in 2011?
Your answer should be very brief. 43.75. What is the difference between the Electricity production(% of total) in Sub-Saharan Africa (developing only) in 2010 and the Electricity production(% of total) in France in 2011?
Give a very brief answer. 1.88. What is the difference between the Electricity production(% of total) of Sub-Saharan Africa (developing only) in 2010 and the Electricity production(% of total) of United Kingdom in 2011?
Offer a terse response. -33.49. What is the difference between the Electricity production(% of total) of Sub-Saharan Africa (developing only) in 2010 and the Electricity production(% of total) of Uruguay in 2011?
Your answer should be compact. 5.82. What is the difference between the Electricity production(% of total) in France in 2010 and the Electricity production(% of total) in United Kingdom in 2011?
Keep it short and to the point. -35.98. What is the difference between the Electricity production(% of total) of France in 2010 and the Electricity production(% of total) of Uruguay in 2011?
Offer a terse response. 3.33. What is the difference between the Electricity production(% of total) in United Kingdom in 2010 and the Electricity production(% of total) in Uruguay in 2011?
Give a very brief answer. 45.52. What is the average Electricity production(% of total) of Sub-Saharan Africa (developing only) per year?
Your response must be concise. 5.84. What is the average Electricity production(% of total) of France per year?
Provide a short and direct response. 4.02. What is the average Electricity production(% of total) of United Kingdom per year?
Give a very brief answer. 41.72. What is the average Electricity production(% of total) of Uruguay per year?
Provide a short and direct response. 0.26. In the year 2004, what is the difference between the Electricity production(% of total) of Sub-Saharan Africa (developing only) and Electricity production(% of total) of France?
Offer a very short reply. 1.69. In the year 2004, what is the difference between the Electricity production(% of total) in Sub-Saharan Africa (developing only) and Electricity production(% of total) in United Kingdom?
Provide a succinct answer. -34.75. In the year 2004, what is the difference between the Electricity production(% of total) of Sub-Saharan Africa (developing only) and Electricity production(% of total) of Uruguay?
Offer a very short reply. 5.36. In the year 2004, what is the difference between the Electricity production(% of total) of France and Electricity production(% of total) of United Kingdom?
Offer a very short reply. -36.44. In the year 2004, what is the difference between the Electricity production(% of total) in France and Electricity production(% of total) in Uruguay?
Your answer should be compact. 3.67. In the year 2004, what is the difference between the Electricity production(% of total) of United Kingdom and Electricity production(% of total) of Uruguay?
Provide a succinct answer. 40.11. In the year 2005, what is the difference between the Electricity production(% of total) of Sub-Saharan Africa (developing only) and Electricity production(% of total) of France?
Keep it short and to the point. 1.5. In the year 2005, what is the difference between the Electricity production(% of total) in Sub-Saharan Africa (developing only) and Electricity production(% of total) in United Kingdom?
Your answer should be very brief. -33.07. In the year 2005, what is the difference between the Electricity production(% of total) of Sub-Saharan Africa (developing only) and Electricity production(% of total) of Uruguay?
Provide a short and direct response. 5.49. In the year 2005, what is the difference between the Electricity production(% of total) in France and Electricity production(% of total) in United Kingdom?
Provide a short and direct response. -34.56. In the year 2005, what is the difference between the Electricity production(% of total) of France and Electricity production(% of total) of Uruguay?
Your answer should be very brief. 4. In the year 2005, what is the difference between the Electricity production(% of total) of United Kingdom and Electricity production(% of total) of Uruguay?
Offer a very short reply. 38.56. In the year 2006, what is the difference between the Electricity production(% of total) in Sub-Saharan Africa (developing only) and Electricity production(% of total) in France?
Provide a succinct answer. 1.77. In the year 2006, what is the difference between the Electricity production(% of total) of Sub-Saharan Africa (developing only) and Electricity production(% of total) of United Kingdom?
Make the answer very short. -30.2. In the year 2006, what is the difference between the Electricity production(% of total) in Sub-Saharan Africa (developing only) and Electricity production(% of total) in Uruguay?
Make the answer very short. 5.54. In the year 2006, what is the difference between the Electricity production(% of total) in France and Electricity production(% of total) in United Kingdom?
Your answer should be very brief. -31.97. In the year 2006, what is the difference between the Electricity production(% of total) of France and Electricity production(% of total) of Uruguay?
Keep it short and to the point. 3.77. In the year 2006, what is the difference between the Electricity production(% of total) of United Kingdom and Electricity production(% of total) of Uruguay?
Your answer should be compact. 35.74. In the year 2007, what is the difference between the Electricity production(% of total) of Sub-Saharan Africa (developing only) and Electricity production(% of total) of France?
Offer a terse response. 1.51. In the year 2007, what is the difference between the Electricity production(% of total) in Sub-Saharan Africa (developing only) and Electricity production(% of total) in United Kingdom?
Your answer should be compact. -36.78. In the year 2007, what is the difference between the Electricity production(% of total) in Sub-Saharan Africa (developing only) and Electricity production(% of total) in Uruguay?
Make the answer very short. 5.39. In the year 2007, what is the difference between the Electricity production(% of total) of France and Electricity production(% of total) of United Kingdom?
Your response must be concise. -38.29. In the year 2007, what is the difference between the Electricity production(% of total) in France and Electricity production(% of total) in Uruguay?
Offer a terse response. 3.88. In the year 2007, what is the difference between the Electricity production(% of total) in United Kingdom and Electricity production(% of total) in Uruguay?
Your answer should be compact. 42.17. In the year 2008, what is the difference between the Electricity production(% of total) in Sub-Saharan Africa (developing only) and Electricity production(% of total) in France?
Your response must be concise. 1.42. In the year 2008, what is the difference between the Electricity production(% of total) of Sub-Saharan Africa (developing only) and Electricity production(% of total) of United Kingdom?
Your answer should be compact. -40.53. In the year 2008, what is the difference between the Electricity production(% of total) of Sub-Saharan Africa (developing only) and Electricity production(% of total) of Uruguay?
Make the answer very short. 5.19. In the year 2008, what is the difference between the Electricity production(% of total) in France and Electricity production(% of total) in United Kingdom?
Ensure brevity in your answer.  -41.95. In the year 2008, what is the difference between the Electricity production(% of total) of France and Electricity production(% of total) of Uruguay?
Provide a succinct answer. 3.76. In the year 2008, what is the difference between the Electricity production(% of total) in United Kingdom and Electricity production(% of total) in Uruguay?
Make the answer very short. 45.72. In the year 2009, what is the difference between the Electricity production(% of total) in Sub-Saharan Africa (developing only) and Electricity production(% of total) in France?
Make the answer very short. 1.59. In the year 2009, what is the difference between the Electricity production(% of total) in Sub-Saharan Africa (developing only) and Electricity production(% of total) in United Kingdom?
Your response must be concise. -39.17. In the year 2009, what is the difference between the Electricity production(% of total) of Sub-Saharan Africa (developing only) and Electricity production(% of total) of Uruguay?
Provide a short and direct response. 5.24. In the year 2009, what is the difference between the Electricity production(% of total) of France and Electricity production(% of total) of United Kingdom?
Offer a very short reply. -40.76. In the year 2009, what is the difference between the Electricity production(% of total) in France and Electricity production(% of total) in Uruguay?
Your answer should be very brief. 3.65. In the year 2009, what is the difference between the Electricity production(% of total) of United Kingdom and Electricity production(% of total) of Uruguay?
Give a very brief answer. 44.42. In the year 2010, what is the difference between the Electricity production(% of total) of Sub-Saharan Africa (developing only) and Electricity production(% of total) of France?
Your response must be concise. 2.49. In the year 2010, what is the difference between the Electricity production(% of total) in Sub-Saharan Africa (developing only) and Electricity production(% of total) in United Kingdom?
Offer a very short reply. -39.69. In the year 2010, what is the difference between the Electricity production(% of total) in Sub-Saharan Africa (developing only) and Electricity production(% of total) in Uruguay?
Provide a short and direct response. 5.98. In the year 2010, what is the difference between the Electricity production(% of total) of France and Electricity production(% of total) of United Kingdom?
Offer a very short reply. -42.19. In the year 2010, what is the difference between the Electricity production(% of total) of France and Electricity production(% of total) of Uruguay?
Offer a very short reply. 3.48. In the year 2010, what is the difference between the Electricity production(% of total) in United Kingdom and Electricity production(% of total) in Uruguay?
Give a very brief answer. 45.67. In the year 2011, what is the difference between the Electricity production(% of total) of Sub-Saharan Africa (developing only) and Electricity production(% of total) of France?
Offer a terse response. 2.53. In the year 2011, what is the difference between the Electricity production(% of total) of Sub-Saharan Africa (developing only) and Electricity production(% of total) of United Kingdom?
Your answer should be very brief. -32.84. In the year 2011, what is the difference between the Electricity production(% of total) in Sub-Saharan Africa (developing only) and Electricity production(% of total) in Uruguay?
Offer a terse response. 6.47. In the year 2011, what is the difference between the Electricity production(% of total) of France and Electricity production(% of total) of United Kingdom?
Make the answer very short. -35.37. In the year 2011, what is the difference between the Electricity production(% of total) in France and Electricity production(% of total) in Uruguay?
Offer a very short reply. 3.94. In the year 2011, what is the difference between the Electricity production(% of total) of United Kingdom and Electricity production(% of total) of Uruguay?
Give a very brief answer. 39.31. What is the ratio of the Electricity production(% of total) in Sub-Saharan Africa (developing only) in 2004 to that in 2005?
Provide a succinct answer. 0.97. What is the ratio of the Electricity production(% of total) in France in 2004 to that in 2005?
Provide a short and direct response. 0.92. What is the ratio of the Electricity production(% of total) of United Kingdom in 2004 to that in 2005?
Ensure brevity in your answer.  1.04. What is the ratio of the Electricity production(% of total) of Uruguay in 2004 to that in 2005?
Keep it short and to the point. 0.87. What is the ratio of the Electricity production(% of total) of Sub-Saharan Africa (developing only) in 2004 to that in 2006?
Provide a succinct answer. 0.96. What is the ratio of the Electricity production(% of total) in France in 2004 to that in 2006?
Your response must be concise. 0.97. What is the ratio of the Electricity production(% of total) of United Kingdom in 2004 to that in 2006?
Offer a terse response. 1.12. What is the ratio of the Electricity production(% of total) in Uruguay in 2004 to that in 2006?
Offer a very short reply. 0.64. What is the ratio of the Electricity production(% of total) in Sub-Saharan Africa (developing only) in 2004 to that in 2007?
Provide a short and direct response. 1. What is the ratio of the Electricity production(% of total) of France in 2004 to that in 2007?
Provide a succinct answer. 0.95. What is the ratio of the Electricity production(% of total) in United Kingdom in 2004 to that in 2007?
Provide a short and direct response. 0.95. What is the ratio of the Electricity production(% of total) of Uruguay in 2004 to that in 2007?
Make the answer very short. 1.6. What is the ratio of the Electricity production(% of total) of Sub-Saharan Africa (developing only) in 2004 to that in 2008?
Your answer should be very brief. 1.02. What is the ratio of the Electricity production(% of total) of France in 2004 to that in 2008?
Your response must be concise. 0.96. What is the ratio of the Electricity production(% of total) of United Kingdom in 2004 to that in 2008?
Offer a terse response. 0.88. What is the ratio of the Electricity production(% of total) of Uruguay in 2004 to that in 2008?
Your answer should be compact. 0.43. What is the ratio of the Electricity production(% of total) of Sub-Saharan Africa (developing only) in 2004 to that in 2009?
Give a very brief answer. 0.99. What is the ratio of the Electricity production(% of total) in France in 2004 to that in 2009?
Offer a very short reply. 0.96. What is the ratio of the Electricity production(% of total) in United Kingdom in 2004 to that in 2009?
Make the answer very short. 0.9. What is the ratio of the Electricity production(% of total) of Uruguay in 2004 to that in 2009?
Your response must be concise. 0.16. What is the ratio of the Electricity production(% of total) in Sub-Saharan Africa (developing only) in 2004 to that in 2010?
Give a very brief answer. 0.8. What is the ratio of the Electricity production(% of total) in France in 2004 to that in 2010?
Ensure brevity in your answer.  0.88. What is the ratio of the Electricity production(% of total) in United Kingdom in 2004 to that in 2010?
Your answer should be compact. 0.87. What is the ratio of the Electricity production(% of total) of Uruguay in 2004 to that in 2010?
Offer a terse response. 0.05. What is the ratio of the Electricity production(% of total) of Sub-Saharan Africa (developing only) in 2004 to that in 2011?
Provide a short and direct response. 0.73. What is the ratio of the Electricity production(% of total) in France in 2004 to that in 2011?
Your answer should be compact. 0.77. What is the ratio of the Electricity production(% of total) of Uruguay in 2004 to that in 2011?
Offer a terse response. 0.04. What is the ratio of the Electricity production(% of total) of Sub-Saharan Africa (developing only) in 2005 to that in 2006?
Your answer should be compact. 0.99. What is the ratio of the Electricity production(% of total) of France in 2005 to that in 2006?
Keep it short and to the point. 1.06. What is the ratio of the Electricity production(% of total) in United Kingdom in 2005 to that in 2006?
Your response must be concise. 1.08. What is the ratio of the Electricity production(% of total) in Uruguay in 2005 to that in 2006?
Make the answer very short. 0.73. What is the ratio of the Electricity production(% of total) of Sub-Saharan Africa (developing only) in 2005 to that in 2007?
Offer a terse response. 1.02. What is the ratio of the Electricity production(% of total) in France in 2005 to that in 2007?
Give a very brief answer. 1.04. What is the ratio of the Electricity production(% of total) of United Kingdom in 2005 to that in 2007?
Offer a very short reply. 0.92. What is the ratio of the Electricity production(% of total) of Uruguay in 2005 to that in 2007?
Offer a terse response. 1.84. What is the ratio of the Electricity production(% of total) in Sub-Saharan Africa (developing only) in 2005 to that in 2008?
Make the answer very short. 1.05. What is the ratio of the Electricity production(% of total) of France in 2005 to that in 2008?
Give a very brief answer. 1.05. What is the ratio of the Electricity production(% of total) in United Kingdom in 2005 to that in 2008?
Provide a succinct answer. 0.84. What is the ratio of the Electricity production(% of total) of Uruguay in 2005 to that in 2008?
Offer a very short reply. 0.49. What is the ratio of the Electricity production(% of total) of Sub-Saharan Africa (developing only) in 2005 to that in 2009?
Make the answer very short. 1.01. What is the ratio of the Electricity production(% of total) of France in 2005 to that in 2009?
Keep it short and to the point. 1.04. What is the ratio of the Electricity production(% of total) in United Kingdom in 2005 to that in 2009?
Your response must be concise. 0.86. What is the ratio of the Electricity production(% of total) of Uruguay in 2005 to that in 2009?
Offer a very short reply. 0.18. What is the ratio of the Electricity production(% of total) in Sub-Saharan Africa (developing only) in 2005 to that in 2010?
Provide a short and direct response. 0.83. What is the ratio of the Electricity production(% of total) in France in 2005 to that in 2010?
Make the answer very short. 0.96. What is the ratio of the Electricity production(% of total) of United Kingdom in 2005 to that in 2010?
Offer a very short reply. 0.83. What is the ratio of the Electricity production(% of total) in Uruguay in 2005 to that in 2010?
Provide a short and direct response. 0.05. What is the ratio of the Electricity production(% of total) in Sub-Saharan Africa (developing only) in 2005 to that in 2011?
Keep it short and to the point. 0.75. What is the ratio of the Electricity production(% of total) in France in 2005 to that in 2011?
Provide a succinct answer. 0.84. What is the ratio of the Electricity production(% of total) in United Kingdom in 2005 to that in 2011?
Your response must be concise. 0.96. What is the ratio of the Electricity production(% of total) in Uruguay in 2005 to that in 2011?
Provide a succinct answer. 0.04. What is the ratio of the Electricity production(% of total) in Sub-Saharan Africa (developing only) in 2006 to that in 2007?
Give a very brief answer. 1.03. What is the ratio of the Electricity production(% of total) of France in 2006 to that in 2007?
Your response must be concise. 0.98. What is the ratio of the Electricity production(% of total) in United Kingdom in 2006 to that in 2007?
Ensure brevity in your answer.  0.85. What is the ratio of the Electricity production(% of total) of Uruguay in 2006 to that in 2007?
Ensure brevity in your answer.  2.52. What is the ratio of the Electricity production(% of total) in Sub-Saharan Africa (developing only) in 2006 to that in 2008?
Provide a succinct answer. 1.06. What is the ratio of the Electricity production(% of total) in France in 2006 to that in 2008?
Provide a succinct answer. 0.99. What is the ratio of the Electricity production(% of total) in United Kingdom in 2006 to that in 2008?
Your answer should be compact. 0.78. What is the ratio of the Electricity production(% of total) in Uruguay in 2006 to that in 2008?
Offer a very short reply. 0.67. What is the ratio of the Electricity production(% of total) in Sub-Saharan Africa (developing only) in 2006 to that in 2009?
Your answer should be very brief. 1.03. What is the ratio of the Electricity production(% of total) in France in 2006 to that in 2009?
Give a very brief answer. 0.99. What is the ratio of the Electricity production(% of total) in United Kingdom in 2006 to that in 2009?
Your answer should be very brief. 0.8. What is the ratio of the Electricity production(% of total) of Uruguay in 2006 to that in 2009?
Offer a terse response. 0.25. What is the ratio of the Electricity production(% of total) in Sub-Saharan Africa (developing only) in 2006 to that in 2010?
Give a very brief answer. 0.83. What is the ratio of the Electricity production(% of total) in France in 2006 to that in 2010?
Offer a very short reply. 0.91. What is the ratio of the Electricity production(% of total) in United Kingdom in 2006 to that in 2010?
Ensure brevity in your answer.  0.77. What is the ratio of the Electricity production(% of total) in Uruguay in 2006 to that in 2010?
Ensure brevity in your answer.  0.07. What is the ratio of the Electricity production(% of total) of Sub-Saharan Africa (developing only) in 2006 to that in 2011?
Your response must be concise. 0.76. What is the ratio of the Electricity production(% of total) in France in 2006 to that in 2011?
Offer a terse response. 0.79. What is the ratio of the Electricity production(% of total) in United Kingdom in 2006 to that in 2011?
Your response must be concise. 0.89. What is the ratio of the Electricity production(% of total) in Uruguay in 2006 to that in 2011?
Your answer should be compact. 0.06. What is the ratio of the Electricity production(% of total) of Sub-Saharan Africa (developing only) in 2007 to that in 2008?
Your answer should be compact. 1.03. What is the ratio of the Electricity production(% of total) of France in 2007 to that in 2008?
Offer a very short reply. 1.01. What is the ratio of the Electricity production(% of total) of United Kingdom in 2007 to that in 2008?
Your response must be concise. 0.92. What is the ratio of the Electricity production(% of total) in Uruguay in 2007 to that in 2008?
Offer a very short reply. 0.27. What is the ratio of the Electricity production(% of total) in Sub-Saharan Africa (developing only) in 2007 to that in 2009?
Ensure brevity in your answer.  0.99. What is the ratio of the Electricity production(% of total) of France in 2007 to that in 2009?
Make the answer very short. 1.01. What is the ratio of the Electricity production(% of total) of United Kingdom in 2007 to that in 2009?
Keep it short and to the point. 0.95. What is the ratio of the Electricity production(% of total) of Uruguay in 2007 to that in 2009?
Offer a very short reply. 0.1. What is the ratio of the Electricity production(% of total) in Sub-Saharan Africa (developing only) in 2007 to that in 2010?
Ensure brevity in your answer.  0.81. What is the ratio of the Electricity production(% of total) of France in 2007 to that in 2010?
Give a very brief answer. 0.93. What is the ratio of the Electricity production(% of total) of United Kingdom in 2007 to that in 2010?
Keep it short and to the point. 0.91. What is the ratio of the Electricity production(% of total) of Uruguay in 2007 to that in 2010?
Offer a very short reply. 0.03. What is the ratio of the Electricity production(% of total) of Sub-Saharan Africa (developing only) in 2007 to that in 2011?
Your response must be concise. 0.74. What is the ratio of the Electricity production(% of total) of France in 2007 to that in 2011?
Your response must be concise. 0.81. What is the ratio of the Electricity production(% of total) in United Kingdom in 2007 to that in 2011?
Your answer should be very brief. 1.05. What is the ratio of the Electricity production(% of total) of Uruguay in 2007 to that in 2011?
Your answer should be very brief. 0.02. What is the ratio of the Electricity production(% of total) of Sub-Saharan Africa (developing only) in 2008 to that in 2009?
Ensure brevity in your answer.  0.97. What is the ratio of the Electricity production(% of total) in France in 2008 to that in 2009?
Your response must be concise. 0.99. What is the ratio of the Electricity production(% of total) in United Kingdom in 2008 to that in 2009?
Keep it short and to the point. 1.03. What is the ratio of the Electricity production(% of total) in Uruguay in 2008 to that in 2009?
Your answer should be compact. 0.37. What is the ratio of the Electricity production(% of total) of Sub-Saharan Africa (developing only) in 2008 to that in 2010?
Offer a terse response. 0.79. What is the ratio of the Electricity production(% of total) of France in 2008 to that in 2010?
Your answer should be compact. 0.91. What is the ratio of the Electricity production(% of total) in United Kingdom in 2008 to that in 2010?
Offer a very short reply. 0.99. What is the ratio of the Electricity production(% of total) in Uruguay in 2008 to that in 2010?
Ensure brevity in your answer.  0.11. What is the ratio of the Electricity production(% of total) in Sub-Saharan Africa (developing only) in 2008 to that in 2011?
Your answer should be very brief. 0.72. What is the ratio of the Electricity production(% of total) in France in 2008 to that in 2011?
Provide a succinct answer. 0.8. What is the ratio of the Electricity production(% of total) of United Kingdom in 2008 to that in 2011?
Your answer should be compact. 1.14. What is the ratio of the Electricity production(% of total) of Uruguay in 2008 to that in 2011?
Your answer should be compact. 0.09. What is the ratio of the Electricity production(% of total) of Sub-Saharan Africa (developing only) in 2009 to that in 2010?
Provide a succinct answer. 0.81. What is the ratio of the Electricity production(% of total) of France in 2009 to that in 2010?
Keep it short and to the point. 0.92. What is the ratio of the Electricity production(% of total) of United Kingdom in 2009 to that in 2010?
Ensure brevity in your answer.  0.96. What is the ratio of the Electricity production(% of total) of Uruguay in 2009 to that in 2010?
Your answer should be very brief. 0.29. What is the ratio of the Electricity production(% of total) in Sub-Saharan Africa (developing only) in 2009 to that in 2011?
Your answer should be compact. 0.74. What is the ratio of the Electricity production(% of total) of France in 2009 to that in 2011?
Make the answer very short. 0.8. What is the ratio of the Electricity production(% of total) of United Kingdom in 2009 to that in 2011?
Your response must be concise. 1.11. What is the ratio of the Electricity production(% of total) in Uruguay in 2009 to that in 2011?
Your answer should be very brief. 0.24. What is the ratio of the Electricity production(% of total) in Sub-Saharan Africa (developing only) in 2010 to that in 2011?
Make the answer very short. 0.91. What is the ratio of the Electricity production(% of total) in France in 2010 to that in 2011?
Your response must be concise. 0.87. What is the ratio of the Electricity production(% of total) in United Kingdom in 2010 to that in 2011?
Keep it short and to the point. 1.15. What is the ratio of the Electricity production(% of total) in Uruguay in 2010 to that in 2011?
Make the answer very short. 0.83. What is the difference between the highest and the second highest Electricity production(% of total) of Sub-Saharan Africa (developing only)?
Your answer should be compact. 0.65. What is the difference between the highest and the second highest Electricity production(% of total) in France?
Keep it short and to the point. 0.61. What is the difference between the highest and the second highest Electricity production(% of total) of United Kingdom?
Provide a succinct answer. 0.6. What is the difference between the highest and the second highest Electricity production(% of total) in Uruguay?
Your answer should be very brief. 0.15. What is the difference between the highest and the lowest Electricity production(% of total) in Sub-Saharan Africa (developing only)?
Ensure brevity in your answer.  2.08. What is the difference between the highest and the lowest Electricity production(% of total) of France?
Provide a succinct answer. 1.12. What is the difference between the highest and the lowest Electricity production(% of total) of United Kingdom?
Your response must be concise. 10.6. What is the difference between the highest and the lowest Electricity production(% of total) of Uruguay?
Your answer should be compact. 0.86. 